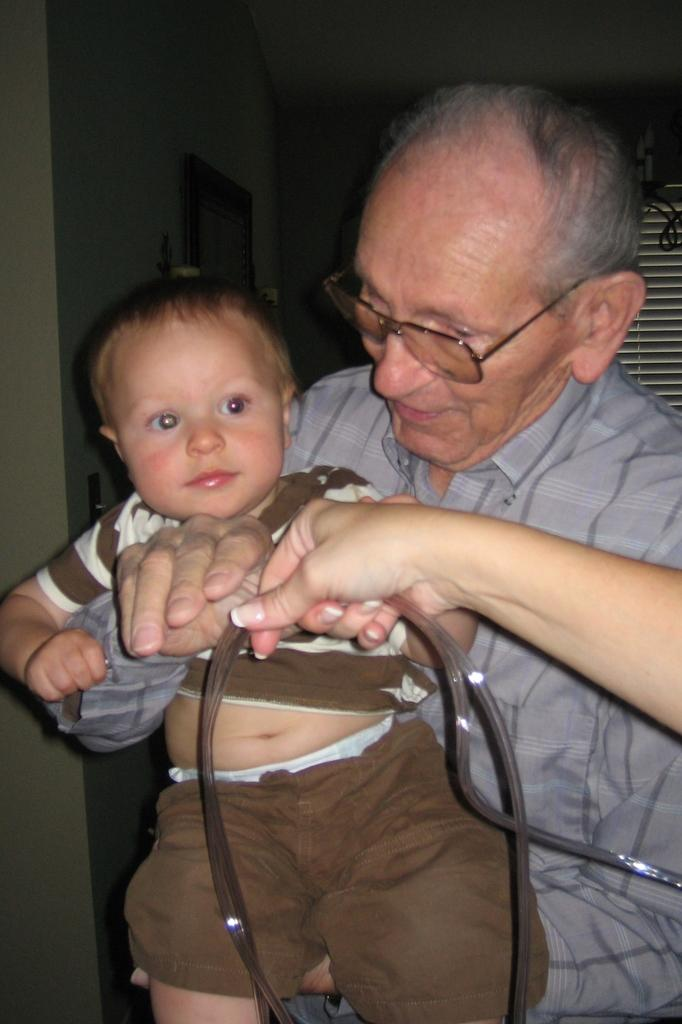What is the man in the image doing? The man is carrying a baby in the image. What else can be seen in the image besides the man and the baby? There is another person's hand holding an object in the image. What is in the background of the image? There is a frame attached to the wall in the background of the image. What type of animal is the man riding in the image? There is no animal present in the image; the man is carrying a baby. 